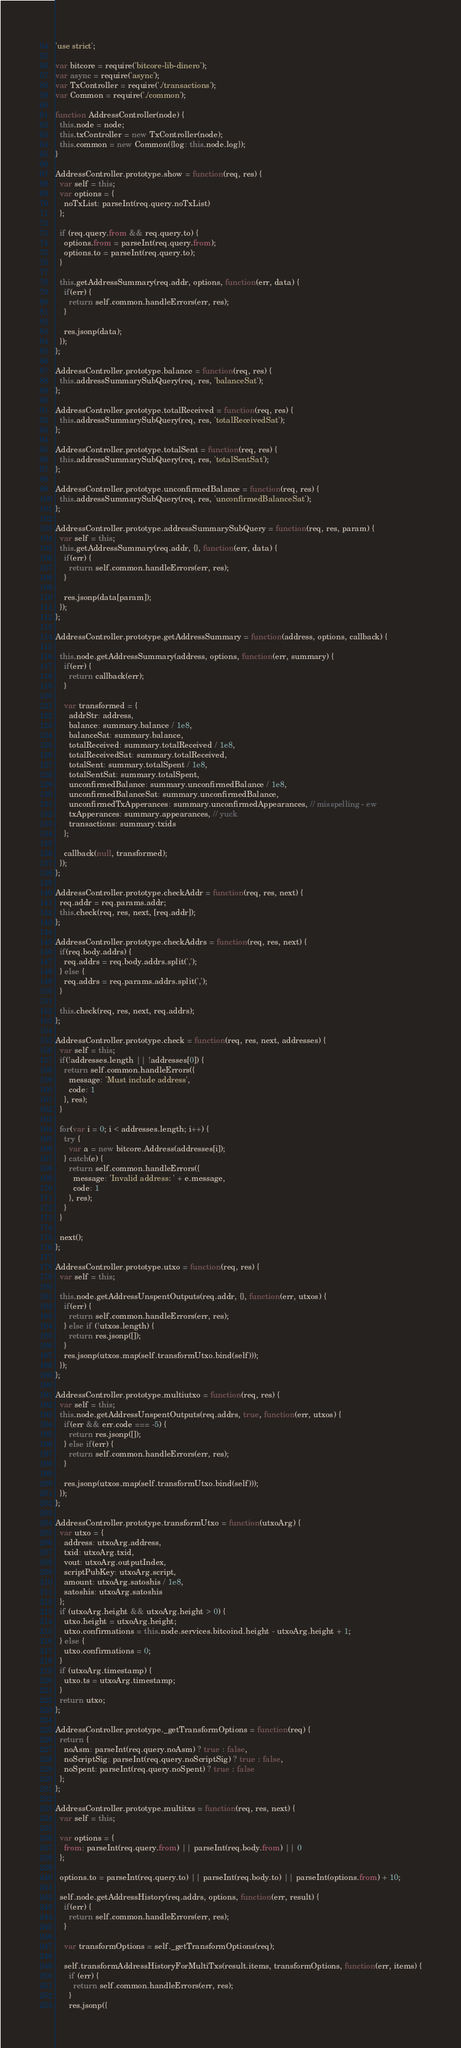Convert code to text. <code><loc_0><loc_0><loc_500><loc_500><_JavaScript_>'use strict';

var bitcore = require('bitcore-lib-dinero');
var async = require('async');
var TxController = require('./transactions');
var Common = require('./common');

function AddressController(node) {
  this.node = node;
  this.txController = new TxController(node);
  this.common = new Common({log: this.node.log});
}

AddressController.prototype.show = function(req, res) {
  var self = this;
  var options = {
    noTxList: parseInt(req.query.noTxList)
  };

  if (req.query.from && req.query.to) {
    options.from = parseInt(req.query.from);
    options.to = parseInt(req.query.to);
  }

  this.getAddressSummary(req.addr, options, function(err, data) {
    if(err) {
      return self.common.handleErrors(err, res);
    }

    res.jsonp(data);
  });
};

AddressController.prototype.balance = function(req, res) {
  this.addressSummarySubQuery(req, res, 'balanceSat');
};

AddressController.prototype.totalReceived = function(req, res) {
  this.addressSummarySubQuery(req, res, 'totalReceivedSat');
};

AddressController.prototype.totalSent = function(req, res) {
  this.addressSummarySubQuery(req, res, 'totalSentSat');
};

AddressController.prototype.unconfirmedBalance = function(req, res) {
  this.addressSummarySubQuery(req, res, 'unconfirmedBalanceSat');
};

AddressController.prototype.addressSummarySubQuery = function(req, res, param) {
  var self = this;
  this.getAddressSummary(req.addr, {}, function(err, data) {
    if(err) {
      return self.common.handleErrors(err, res);
    }

    res.jsonp(data[param]);
  });
};

AddressController.prototype.getAddressSummary = function(address, options, callback) {

  this.node.getAddressSummary(address, options, function(err, summary) {
    if(err) {
      return callback(err);
    }

    var transformed = {
      addrStr: address,
      balance: summary.balance / 1e8,
      balanceSat: summary.balance,
      totalReceived: summary.totalReceived / 1e8,
      totalReceivedSat: summary.totalReceived,
      totalSent: summary.totalSpent / 1e8,
      totalSentSat: summary.totalSpent,
      unconfirmedBalance: summary.unconfirmedBalance / 1e8,
      unconfirmedBalanceSat: summary.unconfirmedBalance,
      unconfirmedTxApperances: summary.unconfirmedAppearances, // misspelling - ew
      txApperances: summary.appearances, // yuck
      transactions: summary.txids
    };

    callback(null, transformed);
  });
};

AddressController.prototype.checkAddr = function(req, res, next) {
  req.addr = req.params.addr;
  this.check(req, res, next, [req.addr]);
};

AddressController.prototype.checkAddrs = function(req, res, next) {
  if(req.body.addrs) {
    req.addrs = req.body.addrs.split(',');
  } else {
    req.addrs = req.params.addrs.split(',');
  }

  this.check(req, res, next, req.addrs);
};

AddressController.prototype.check = function(req, res, next, addresses) {
  var self = this;
  if(!addresses.length || !addresses[0]) {
    return self.common.handleErrors({
      message: 'Must include address',
      code: 1
    }, res);
  }

  for(var i = 0; i < addresses.length; i++) {
    try {
      var a = new bitcore.Address(addresses[i]);
    } catch(e) {
      return self.common.handleErrors({
        message: 'Invalid address: ' + e.message,
        code: 1
      }, res);
    }
  }

  next();
};

AddressController.prototype.utxo = function(req, res) {
  var self = this;

  this.node.getAddressUnspentOutputs(req.addr, {}, function(err, utxos) {
    if(err) {
      return self.common.handleErrors(err, res);
    } else if (!utxos.length) {
      return res.jsonp([]);
    }
    res.jsonp(utxos.map(self.transformUtxo.bind(self)));
  });
};

AddressController.prototype.multiutxo = function(req, res) {
  var self = this;
  this.node.getAddressUnspentOutputs(req.addrs, true, function(err, utxos) {
    if(err && err.code === -5) {
      return res.jsonp([]);
    } else if(err) {
      return self.common.handleErrors(err, res);
    }

    res.jsonp(utxos.map(self.transformUtxo.bind(self)));
  });
};

AddressController.prototype.transformUtxo = function(utxoArg) {
  var utxo = {
    address: utxoArg.address,
    txid: utxoArg.txid,
    vout: utxoArg.outputIndex,
    scriptPubKey: utxoArg.script,
    amount: utxoArg.satoshis / 1e8,
    satoshis: utxoArg.satoshis
  };
  if (utxoArg.height && utxoArg.height > 0) {
    utxo.height = utxoArg.height;
    utxo.confirmations = this.node.services.bitcoind.height - utxoArg.height + 1;
  } else {
    utxo.confirmations = 0;
  }
  if (utxoArg.timestamp) {
    utxo.ts = utxoArg.timestamp;
  }
  return utxo;
};

AddressController.prototype._getTransformOptions = function(req) {
  return {
    noAsm: parseInt(req.query.noAsm) ? true : false,
    noScriptSig: parseInt(req.query.noScriptSig) ? true : false,
    noSpent: parseInt(req.query.noSpent) ? true : false
  };
};

AddressController.prototype.multitxs = function(req, res, next) {
  var self = this;

  var options = {
    from: parseInt(req.query.from) || parseInt(req.body.from) || 0
  };

  options.to = parseInt(req.query.to) || parseInt(req.body.to) || parseInt(options.from) + 10;

  self.node.getAddressHistory(req.addrs, options, function(err, result) {
    if(err) {
      return self.common.handleErrors(err, res);
    }

    var transformOptions = self._getTransformOptions(req);

    self.transformAddressHistoryForMultiTxs(result.items, transformOptions, function(err, items) {
      if (err) {
        return self.common.handleErrors(err, res);
      }
      res.jsonp({</code> 